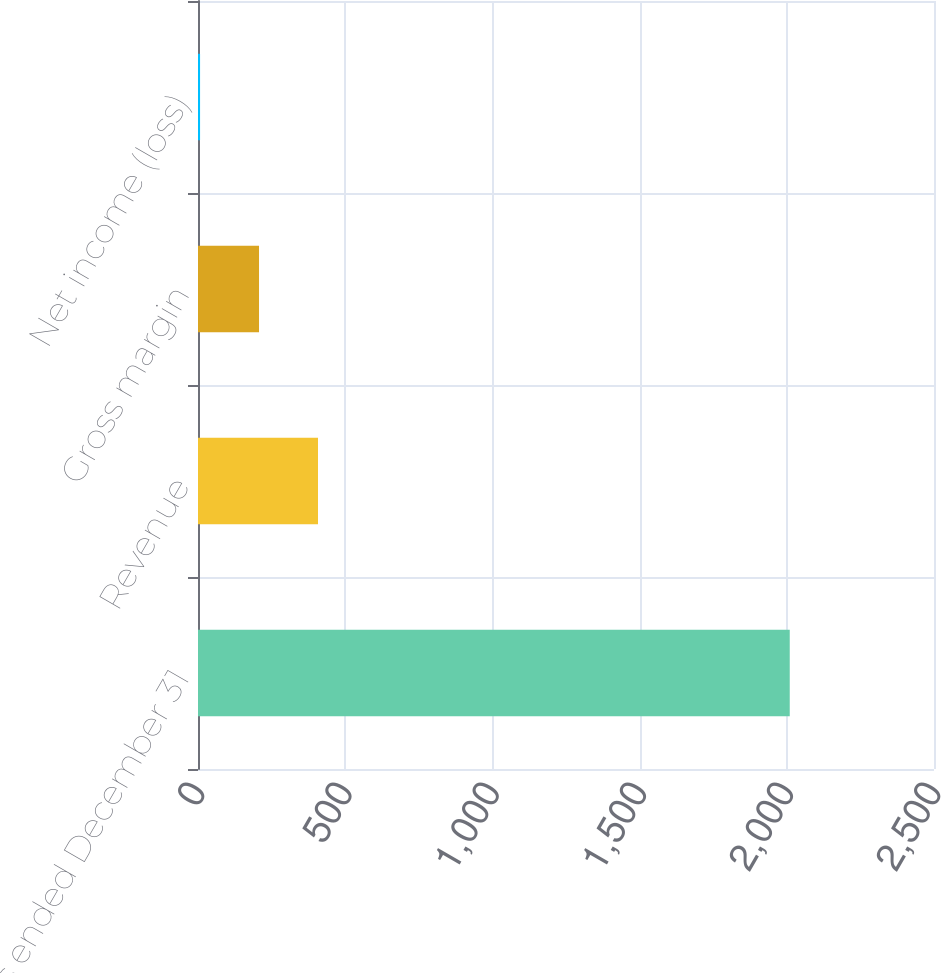Convert chart to OTSL. <chart><loc_0><loc_0><loc_500><loc_500><bar_chart><fcel>Years ended December 31<fcel>Revenue<fcel>Gross margin<fcel>Net income (loss)<nl><fcel>2010<fcel>407.6<fcel>207.3<fcel>7<nl></chart> 